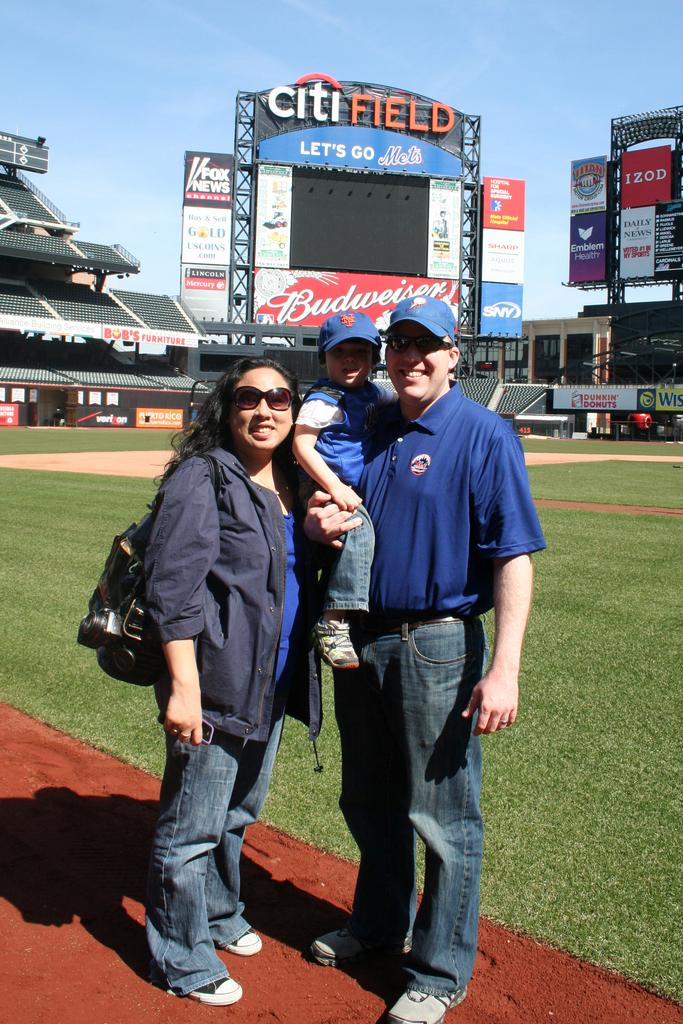<image>
Give a short and clear explanation of the subsequent image. a man, woman, and child posing in front of Citi Field 